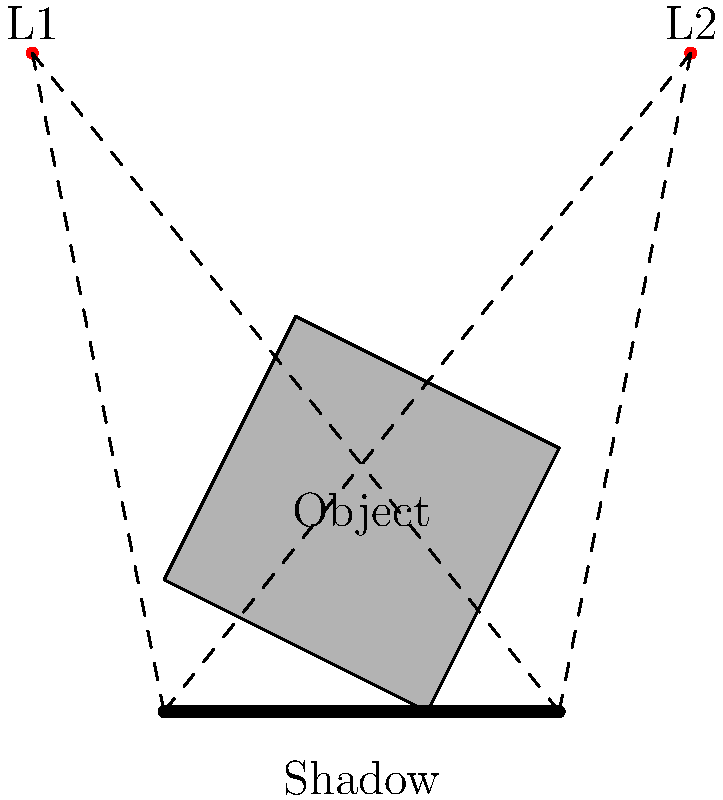In the diagram, an irregularly shaped object is illuminated by two point light sources, L1 and L2. Given the positions of the light sources and the object's shape, predict the pattern of the resulting shadow on the ground. How many distinct regions of shadow intensity would you expect to observe, and why? To solve this problem, we need to consider how light interacts with objects and creates shadows. Let's break it down step-by-step:

1. Light propagation: Light travels in straight lines from each source.

2. Shadow formation: Shadows form in areas where light is blocked by the object.

3. Analyzing light sources:
   - L1 is positioned to the left and above the object.
   - L2 is positioned to the right and above the object.

4. Shadow regions:
   a) Full shadow (umbra): Areas where light from both sources is blocked.
   b) Partial shadow (penumbra): Areas where light from one source is blocked, but not the other.
   c) Fully lit areas: Where light from both sources reaches.

5. Examining the object's shape:
   - The object has an irregular shape with four vertices.
   - Each vertex will cast a shadow line from both light sources.

6. Shadow analysis:
   - The leftmost part of the shadow is created by L1 and the leftmost point of the object.
   - The rightmost part of the shadow is created by L2 and the rightmost point of the object.
   - Between these extremes, there will be regions of varying darkness.

7. Counting distinct regions:
   - Fully lit area (outside the shadow)
   - Left penumbra (blocked by L1 only)
   - Central umbra (blocked by both L1 and L2)
   - Right penumbra (blocked by L2 only)

Therefore, we expect to observe 4 distinct regions of shadow intensity.
Answer: 4 regions 